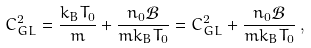<formula> <loc_0><loc_0><loc_500><loc_500>C _ { G L } ^ { 2 } = \frac { k _ { B } T _ { 0 } } { m } + \frac { n _ { 0 } \mathcal { B } } { m k _ { B } T _ { 0 } } = C _ { G L } ^ { 2 } + \frac { n _ { 0 } \mathcal { B } } { m k _ { B } T _ { 0 } } \, ,</formula> 